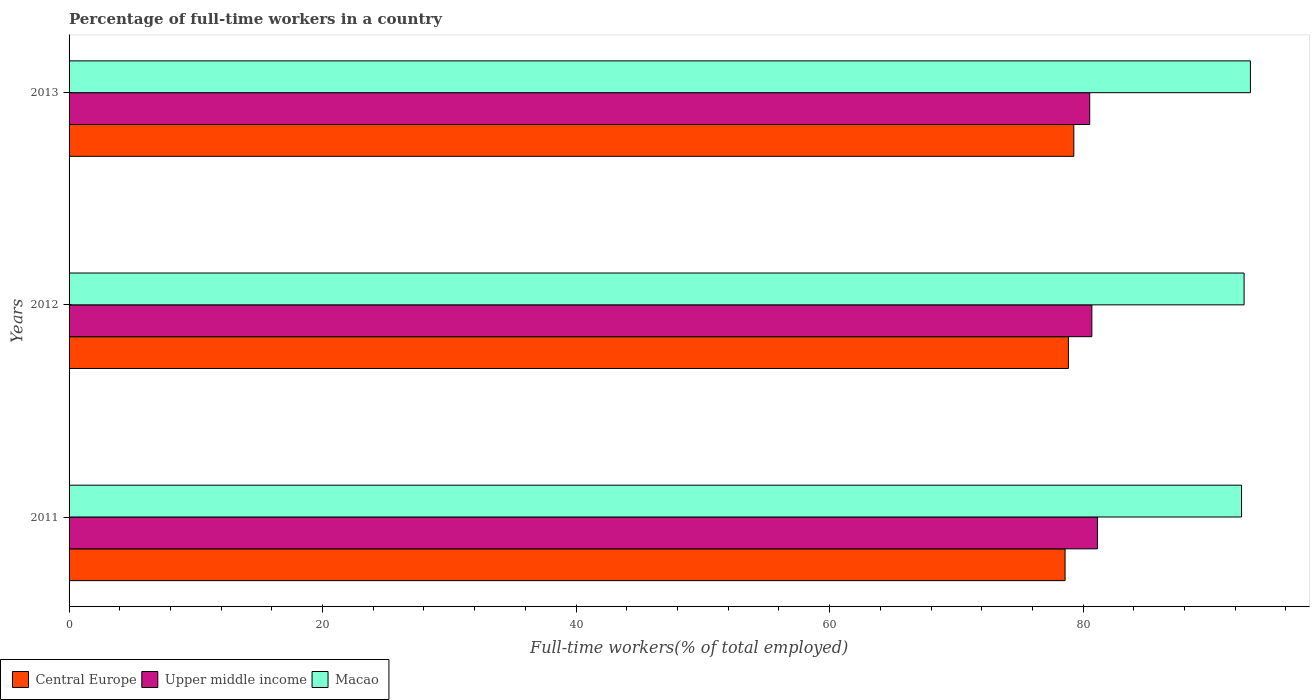How many different coloured bars are there?
Your answer should be compact. 3. Are the number of bars per tick equal to the number of legend labels?
Provide a short and direct response. Yes. How many bars are there on the 2nd tick from the top?
Your answer should be compact. 3. How many bars are there on the 2nd tick from the bottom?
Your response must be concise. 3. What is the label of the 2nd group of bars from the top?
Offer a very short reply. 2012. What is the percentage of full-time workers in Central Europe in 2012?
Give a very brief answer. 78.84. Across all years, what is the maximum percentage of full-time workers in Upper middle income?
Ensure brevity in your answer.  81.13. Across all years, what is the minimum percentage of full-time workers in Central Europe?
Your response must be concise. 78.58. In which year was the percentage of full-time workers in Macao maximum?
Your answer should be very brief. 2013. What is the total percentage of full-time workers in Upper middle income in the graph?
Your response must be concise. 242.34. What is the difference between the percentage of full-time workers in Macao in 2011 and that in 2012?
Provide a short and direct response. -0.2. What is the difference between the percentage of full-time workers in Macao in 2013 and the percentage of full-time workers in Central Europe in 2012?
Give a very brief answer. 14.36. What is the average percentage of full-time workers in Macao per year?
Provide a short and direct response. 92.8. In the year 2013, what is the difference between the percentage of full-time workers in Central Europe and percentage of full-time workers in Upper middle income?
Keep it short and to the point. -1.25. In how many years, is the percentage of full-time workers in Macao greater than 48 %?
Provide a succinct answer. 3. What is the ratio of the percentage of full-time workers in Upper middle income in 2011 to that in 2013?
Your answer should be compact. 1.01. Is the percentage of full-time workers in Upper middle income in 2012 less than that in 2013?
Your response must be concise. No. What is the difference between the highest and the second highest percentage of full-time workers in Upper middle income?
Provide a short and direct response. 0.44. What is the difference between the highest and the lowest percentage of full-time workers in Upper middle income?
Your answer should be compact. 0.61. What does the 1st bar from the top in 2011 represents?
Make the answer very short. Macao. What does the 2nd bar from the bottom in 2013 represents?
Make the answer very short. Upper middle income. Are all the bars in the graph horizontal?
Your answer should be very brief. Yes. Are the values on the major ticks of X-axis written in scientific E-notation?
Offer a very short reply. No. Does the graph contain grids?
Make the answer very short. No. How are the legend labels stacked?
Provide a succinct answer. Horizontal. What is the title of the graph?
Give a very brief answer. Percentage of full-time workers in a country. What is the label or title of the X-axis?
Your answer should be very brief. Full-time workers(% of total employed). What is the Full-time workers(% of total employed) in Central Europe in 2011?
Your answer should be compact. 78.58. What is the Full-time workers(% of total employed) of Upper middle income in 2011?
Your answer should be very brief. 81.13. What is the Full-time workers(% of total employed) in Macao in 2011?
Your answer should be very brief. 92.5. What is the Full-time workers(% of total employed) in Central Europe in 2012?
Your response must be concise. 78.84. What is the Full-time workers(% of total employed) in Upper middle income in 2012?
Your answer should be compact. 80.69. What is the Full-time workers(% of total employed) of Macao in 2012?
Provide a succinct answer. 92.7. What is the Full-time workers(% of total employed) of Central Europe in 2013?
Your answer should be very brief. 79.27. What is the Full-time workers(% of total employed) of Upper middle income in 2013?
Offer a very short reply. 80.52. What is the Full-time workers(% of total employed) in Macao in 2013?
Give a very brief answer. 93.2. Across all years, what is the maximum Full-time workers(% of total employed) in Central Europe?
Keep it short and to the point. 79.27. Across all years, what is the maximum Full-time workers(% of total employed) of Upper middle income?
Your response must be concise. 81.13. Across all years, what is the maximum Full-time workers(% of total employed) in Macao?
Provide a short and direct response. 93.2. Across all years, what is the minimum Full-time workers(% of total employed) of Central Europe?
Make the answer very short. 78.58. Across all years, what is the minimum Full-time workers(% of total employed) of Upper middle income?
Your response must be concise. 80.52. Across all years, what is the minimum Full-time workers(% of total employed) of Macao?
Offer a very short reply. 92.5. What is the total Full-time workers(% of total employed) in Central Europe in the graph?
Your answer should be compact. 236.68. What is the total Full-time workers(% of total employed) in Upper middle income in the graph?
Provide a short and direct response. 242.34. What is the total Full-time workers(% of total employed) in Macao in the graph?
Keep it short and to the point. 278.4. What is the difference between the Full-time workers(% of total employed) of Central Europe in 2011 and that in 2012?
Give a very brief answer. -0.26. What is the difference between the Full-time workers(% of total employed) in Upper middle income in 2011 and that in 2012?
Keep it short and to the point. 0.44. What is the difference between the Full-time workers(% of total employed) of Macao in 2011 and that in 2012?
Your answer should be very brief. -0.2. What is the difference between the Full-time workers(% of total employed) of Central Europe in 2011 and that in 2013?
Keep it short and to the point. -0.69. What is the difference between the Full-time workers(% of total employed) in Upper middle income in 2011 and that in 2013?
Give a very brief answer. 0.61. What is the difference between the Full-time workers(% of total employed) in Central Europe in 2012 and that in 2013?
Offer a very short reply. -0.43. What is the difference between the Full-time workers(% of total employed) in Upper middle income in 2012 and that in 2013?
Make the answer very short. 0.17. What is the difference between the Full-time workers(% of total employed) of Central Europe in 2011 and the Full-time workers(% of total employed) of Upper middle income in 2012?
Offer a terse response. -2.11. What is the difference between the Full-time workers(% of total employed) in Central Europe in 2011 and the Full-time workers(% of total employed) in Macao in 2012?
Ensure brevity in your answer.  -14.12. What is the difference between the Full-time workers(% of total employed) of Upper middle income in 2011 and the Full-time workers(% of total employed) of Macao in 2012?
Your answer should be compact. -11.57. What is the difference between the Full-time workers(% of total employed) of Central Europe in 2011 and the Full-time workers(% of total employed) of Upper middle income in 2013?
Offer a terse response. -1.94. What is the difference between the Full-time workers(% of total employed) in Central Europe in 2011 and the Full-time workers(% of total employed) in Macao in 2013?
Offer a very short reply. -14.62. What is the difference between the Full-time workers(% of total employed) in Upper middle income in 2011 and the Full-time workers(% of total employed) in Macao in 2013?
Offer a very short reply. -12.07. What is the difference between the Full-time workers(% of total employed) of Central Europe in 2012 and the Full-time workers(% of total employed) of Upper middle income in 2013?
Your answer should be compact. -1.68. What is the difference between the Full-time workers(% of total employed) in Central Europe in 2012 and the Full-time workers(% of total employed) in Macao in 2013?
Give a very brief answer. -14.36. What is the difference between the Full-time workers(% of total employed) of Upper middle income in 2012 and the Full-time workers(% of total employed) of Macao in 2013?
Offer a terse response. -12.51. What is the average Full-time workers(% of total employed) in Central Europe per year?
Your response must be concise. 78.89. What is the average Full-time workers(% of total employed) of Upper middle income per year?
Give a very brief answer. 80.78. What is the average Full-time workers(% of total employed) in Macao per year?
Your answer should be very brief. 92.8. In the year 2011, what is the difference between the Full-time workers(% of total employed) in Central Europe and Full-time workers(% of total employed) in Upper middle income?
Your answer should be compact. -2.55. In the year 2011, what is the difference between the Full-time workers(% of total employed) of Central Europe and Full-time workers(% of total employed) of Macao?
Make the answer very short. -13.92. In the year 2011, what is the difference between the Full-time workers(% of total employed) of Upper middle income and Full-time workers(% of total employed) of Macao?
Your response must be concise. -11.37. In the year 2012, what is the difference between the Full-time workers(% of total employed) in Central Europe and Full-time workers(% of total employed) in Upper middle income?
Offer a terse response. -1.85. In the year 2012, what is the difference between the Full-time workers(% of total employed) in Central Europe and Full-time workers(% of total employed) in Macao?
Keep it short and to the point. -13.86. In the year 2012, what is the difference between the Full-time workers(% of total employed) in Upper middle income and Full-time workers(% of total employed) in Macao?
Provide a short and direct response. -12.01. In the year 2013, what is the difference between the Full-time workers(% of total employed) of Central Europe and Full-time workers(% of total employed) of Upper middle income?
Make the answer very short. -1.25. In the year 2013, what is the difference between the Full-time workers(% of total employed) in Central Europe and Full-time workers(% of total employed) in Macao?
Your answer should be compact. -13.93. In the year 2013, what is the difference between the Full-time workers(% of total employed) in Upper middle income and Full-time workers(% of total employed) in Macao?
Your answer should be compact. -12.68. What is the ratio of the Full-time workers(% of total employed) of Upper middle income in 2011 to that in 2012?
Give a very brief answer. 1.01. What is the ratio of the Full-time workers(% of total employed) in Upper middle income in 2011 to that in 2013?
Keep it short and to the point. 1.01. What is the ratio of the Full-time workers(% of total employed) of Macao in 2011 to that in 2013?
Your answer should be compact. 0.99. What is the ratio of the Full-time workers(% of total employed) of Macao in 2012 to that in 2013?
Provide a short and direct response. 0.99. What is the difference between the highest and the second highest Full-time workers(% of total employed) of Central Europe?
Your response must be concise. 0.43. What is the difference between the highest and the second highest Full-time workers(% of total employed) in Upper middle income?
Your response must be concise. 0.44. What is the difference between the highest and the lowest Full-time workers(% of total employed) in Central Europe?
Keep it short and to the point. 0.69. What is the difference between the highest and the lowest Full-time workers(% of total employed) in Upper middle income?
Offer a very short reply. 0.61. What is the difference between the highest and the lowest Full-time workers(% of total employed) of Macao?
Give a very brief answer. 0.7. 